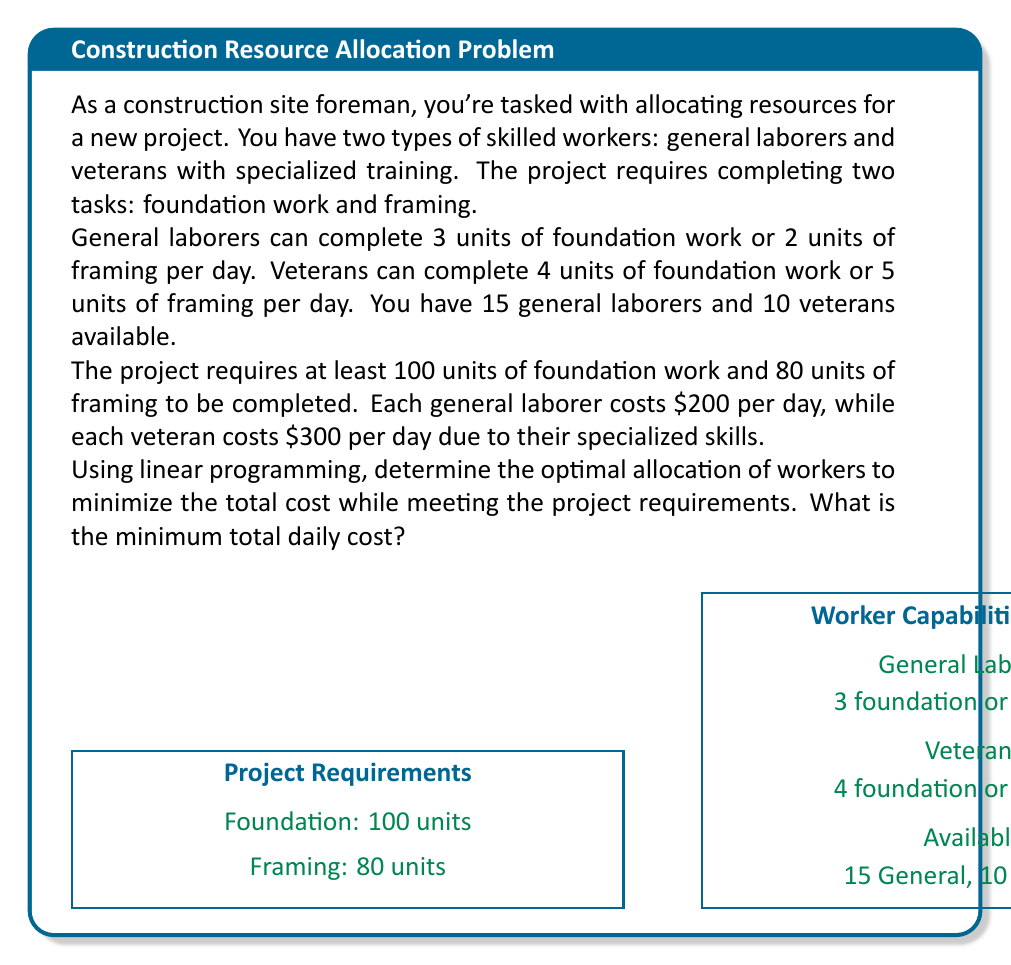Give your solution to this math problem. Let's solve this problem using linear programming:

1) Define variables:
   $x$ = number of general laborers assigned
   $y$ = number of veterans assigned

2) Objective function (to minimize):
   Total cost = $200x + 300y$

3) Constraints:
   a) Foundation work: $3x + 4y \geq 100$
   b) Framing: $2x + 5y \geq 80$
   c) Available workers: $x \leq 15$, $y \leq 10$
   d) Non-negativity: $x \geq 0$, $y \geq 0$

4) Set up the linear program:
   Minimize: $z = 200x + 300y$
   Subject to:
   $3x + 4y \geq 100$
   $2x + 5y \geq 80$
   $x \leq 15$
   $y \leq 10$
   $x, y \geq 0$

5) Solve using the graphical method or simplex algorithm. The optimal solution is at the intersection of constraints:

   $3x + 4y = 100$
   $2x + 5y = 80$

6) Solving these equations:
   $15x + 20y = 500$
   $8x + 20y = 320$
   Subtracting, we get: $7x = 180$
   $x = 25.71$

   Substituting back:
   $2(25.71) + 5y = 80$
   $51.42 + 5y = 80$
   $5y = 28.58$
   $y = 5.72$

7) Since we can't use fractional workers, we round up to the nearest whole number:
   $x = 26$ general laborers
   $y = 6$ veterans

8) Check if this solution satisfies all constraints:
   Foundation: $3(26) + 4(6) = 102 \geq 100$
   Framing: $2(26) + 5(6) = 82 \geq 80$
   Available workers: $26 > 15$, $6 < 10$

9) The solution exceeds the available general laborers. We need to adjust:
   Use all 15 general laborers and solve for veterans:
   $3(15) + 4y = 100$
   $45 + 4y = 100$
   $4y = 55$
   $y = 13.75$

   Round up: $y = 14$ veterans

10) Final check:
    Foundation: $3(15) + 4(14) = 101 \geq 100$
    Framing: $2(15) + 5(14) = 100 \geq 80$
    Available workers: $15 = 15$, $14 > 10$

11) Calculate the total daily cost:
    Cost = $200(15) + 300(14) = 3000 + 4200 = 7200$

Therefore, the minimum total daily cost is $7200, using all 15 general laborers and 14 veterans. Note that this exceeds the initial veteran availability, so in practice, you may need to hire additional veterans or adjust the project timeline.
Answer: $7200 